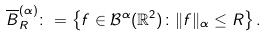<formula> <loc_0><loc_0><loc_500><loc_500>\overline { B } _ { R } ^ { ( \alpha ) } \colon = \left \{ f \in \mathcal { B } ^ { \alpha } ( \mathbb { R } ^ { 2 } ) \colon \| f \| _ { \alpha } \leq R \right \} .</formula> 